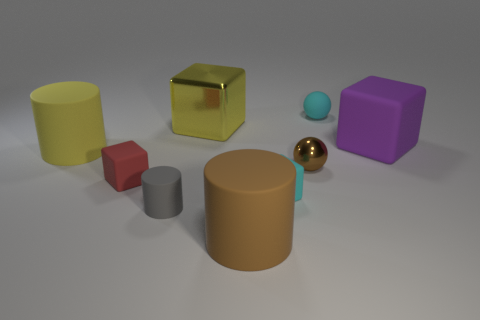What is the shape of the tiny matte object behind the metallic object in front of the big purple block?
Offer a terse response. Sphere. How many things are small brown metallic objects or tiny rubber things in front of the small brown metal thing?
Keep it short and to the point. 4. What number of other things are there of the same color as the large matte block?
Ensure brevity in your answer.  0. How many brown things are either metallic blocks or large objects?
Offer a very short reply. 1. There is a block that is right of the rubber thing that is behind the purple object; is there a large yellow metal thing behind it?
Ensure brevity in your answer.  Yes. What color is the sphere in front of the cyan thing that is behind the tiny brown thing?
Give a very brief answer. Brown. What number of small things are either brown cylinders or green rubber cubes?
Provide a short and direct response. 0. The rubber thing that is to the left of the tiny brown ball and behind the small brown thing is what color?
Your response must be concise. Yellow. Is the material of the tiny brown object the same as the yellow cube?
Provide a short and direct response. Yes. What is the shape of the tiny shiny thing?
Provide a succinct answer. Sphere. 